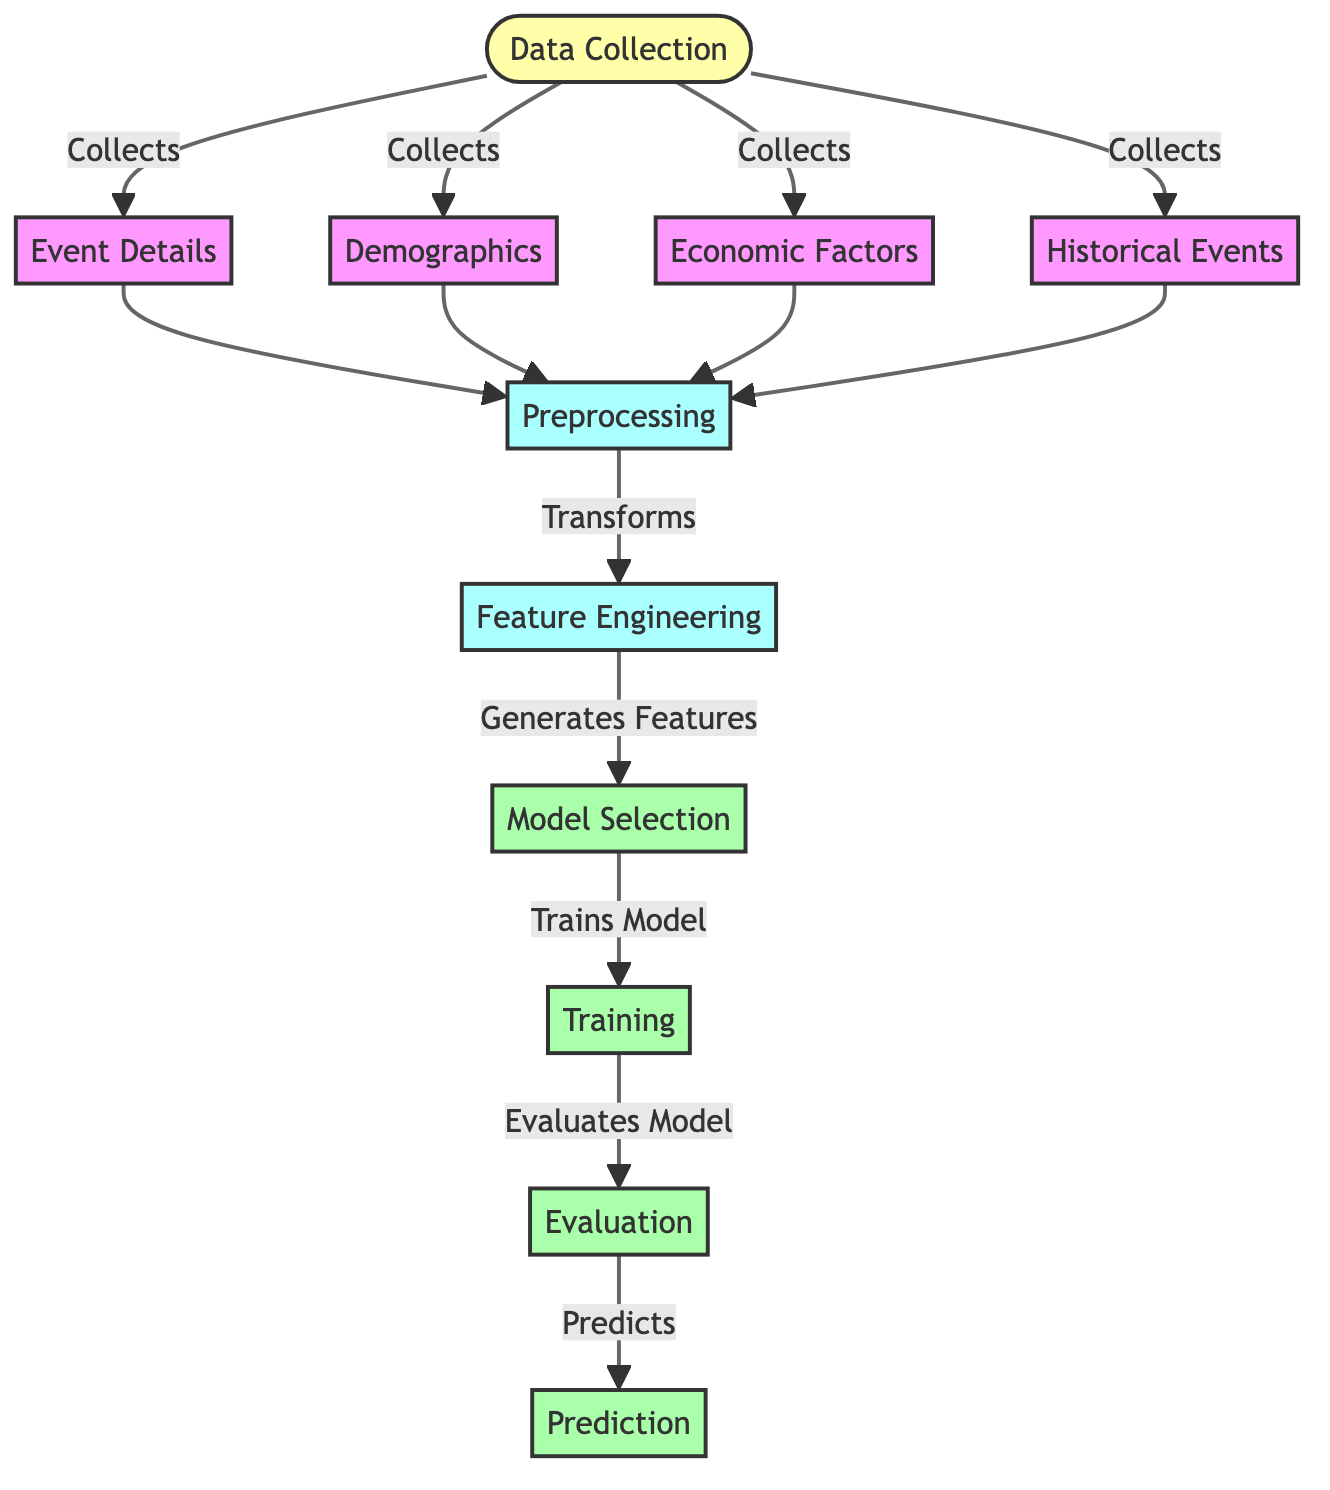What is the first step in the diagram? The first step in the diagram is "Data Collection," which collects four types of information: event details, demographics, economic factors, and historical events. Therefore, the first point of action is gathering relevant data.
Answer: Data Collection How many nodes are present in the diagram? The diagram contains a total of ten nodes, including both the specific content nodes and the processing steps outlined in the flow. This includes the data collection node, four data types collected, and steps related to preprocessing, feature engineering, model selection, training, evaluation, and prediction.
Answer: Ten What type of data is collected along with event details? In addition to "event details," the diagram shows that "demographics," "economic factors," and "historical events" are also collected during the data collection phase. These data types are integral to understanding factors that influence community events.
Answer: Demographics, Economic Factors, Historical Events Which node immediately follows "Preprocessing"? After the "Preprocessing" node, the next step is "Feature Engineering." This transformation step involves generating features that will be used for the subsequent model selection process.
Answer: Feature Engineering How does the diagram depict the relationship between "Model Selection" and "Training"? The diagram shows that "Model Selection" leads directly to "Training," indicating that once a model is selected, the training process will commence immediately afterwards. This emphasizes the flow where model selection is the precursor to model training.
Answer: Training What is the final output step in the flowchart? The final output of the diagram is "Prediction," which follows the "Evaluation" step, highlighting that the output of the classification model is to make predictions based on the trained and evaluated model.
Answer: Prediction Which nodes are categorized as part of the "process"? The nodes categorized as part of the "process" include "Preprocessing," "Feature Engineering," "Model Selection," "Training," and "Evaluation." These nodes all involve actions performed on the collected data to prepare it for prediction.
Answer: Preprocessing, Feature Engineering, Model Selection, Training, Evaluation What action transforms the data before generating features? The action that transforms the data before generating features is called "Preprocessing." This step is essential for preparing collected data for further analysis and feature generation.
Answer: Preprocessing How many data types are collected in total? There are a total of four data types collected in the diagram, which are: event details, demographics, economic factors, and historical events. Each type contributes uniquely to understanding the popularity of community events.
Answer: Four 